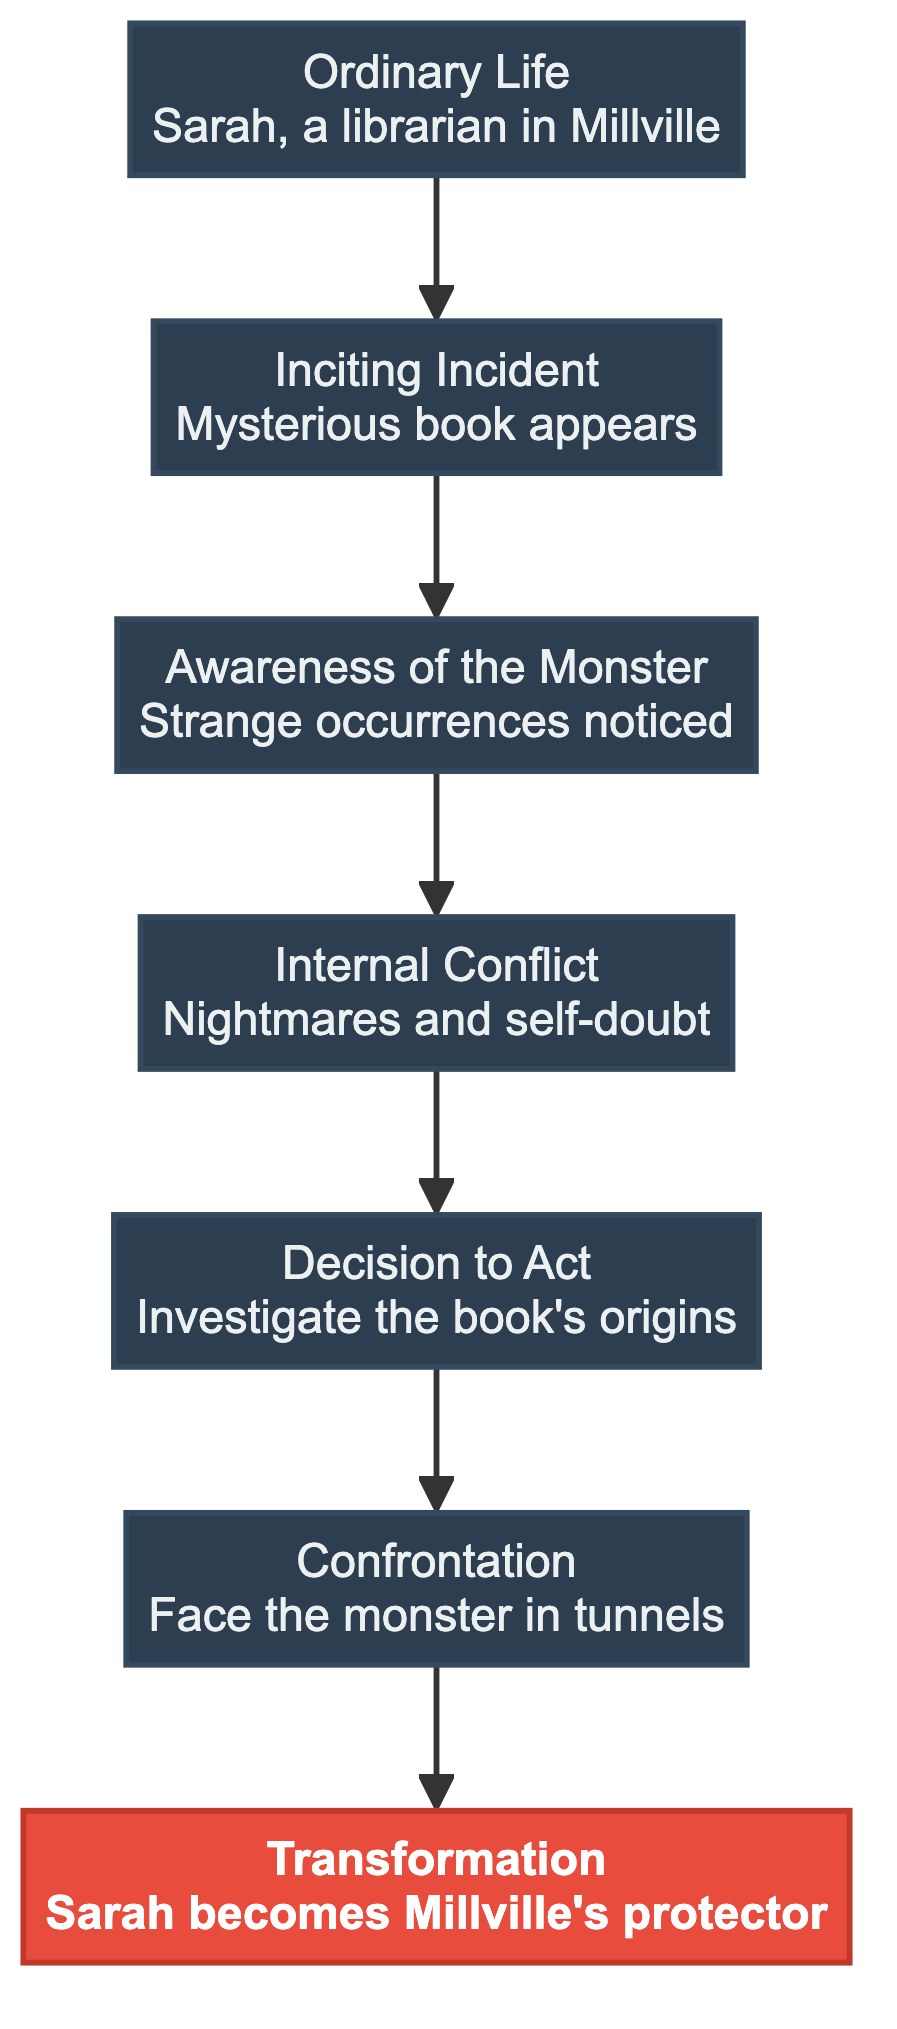What is the first stage in the flow chart? The first stage in the flow chart is labeled "Ordinary Life," which begins the protagonist's journey.
Answer: Ordinary Life How many stages are represented in the flow chart? Counting the stages from "Ordinary Life" to "Transformation," we find there are a total of seven stages in the diagram.
Answer: 7 What event disrupts the protagonist's ordinary life? The event that disrupts the protagonist's ordinary life is labeled "Inciting Incident," indicating a significant change occurs at this point.
Answer: Mysterious book appears What does the "Confrontation" stage indicate? The "Confrontation" stage represents a key moment where the protagonist faces the monster, marking a climactic point in the story.
Answer: Face the monster in tunnels What follows after "Internal Conflict" in the transformation process? After "Internal Conflict," the next stage is "Decision to Act," which signifies the protagonist's choice to confront the looming threat.
Answer: Decision to Act Which stage represents the protagonist's ultimate change? The stage labeled "Transformation" illustrates the protagonist's ultimate change as she adapts to the horrors faced.
Answer: Transformation How is "Awareness of the Monster" important in the storyline? "Awareness of the Monster" serves as a pivotal point where the protagonist begins to recognize the presence of the threat, making it crucial for the unfolding plot.
Answer: Strange occurrences noticed Which stage leads directly to the confrontation with the monster? The "Decision to Act" stage leads directly to the "Confrontation," indicating the progression to facing the antagonist.
Answer: Decision to Act How does the flow of the chart guide the protagonist's journey? The bottom-to-top flow chart illustrates the protagonist's journey from the initial ordinary life, through various challenges leading to the final confrontation, visually guiding the reader through her transformation.
Answer: Confronting the Monster 